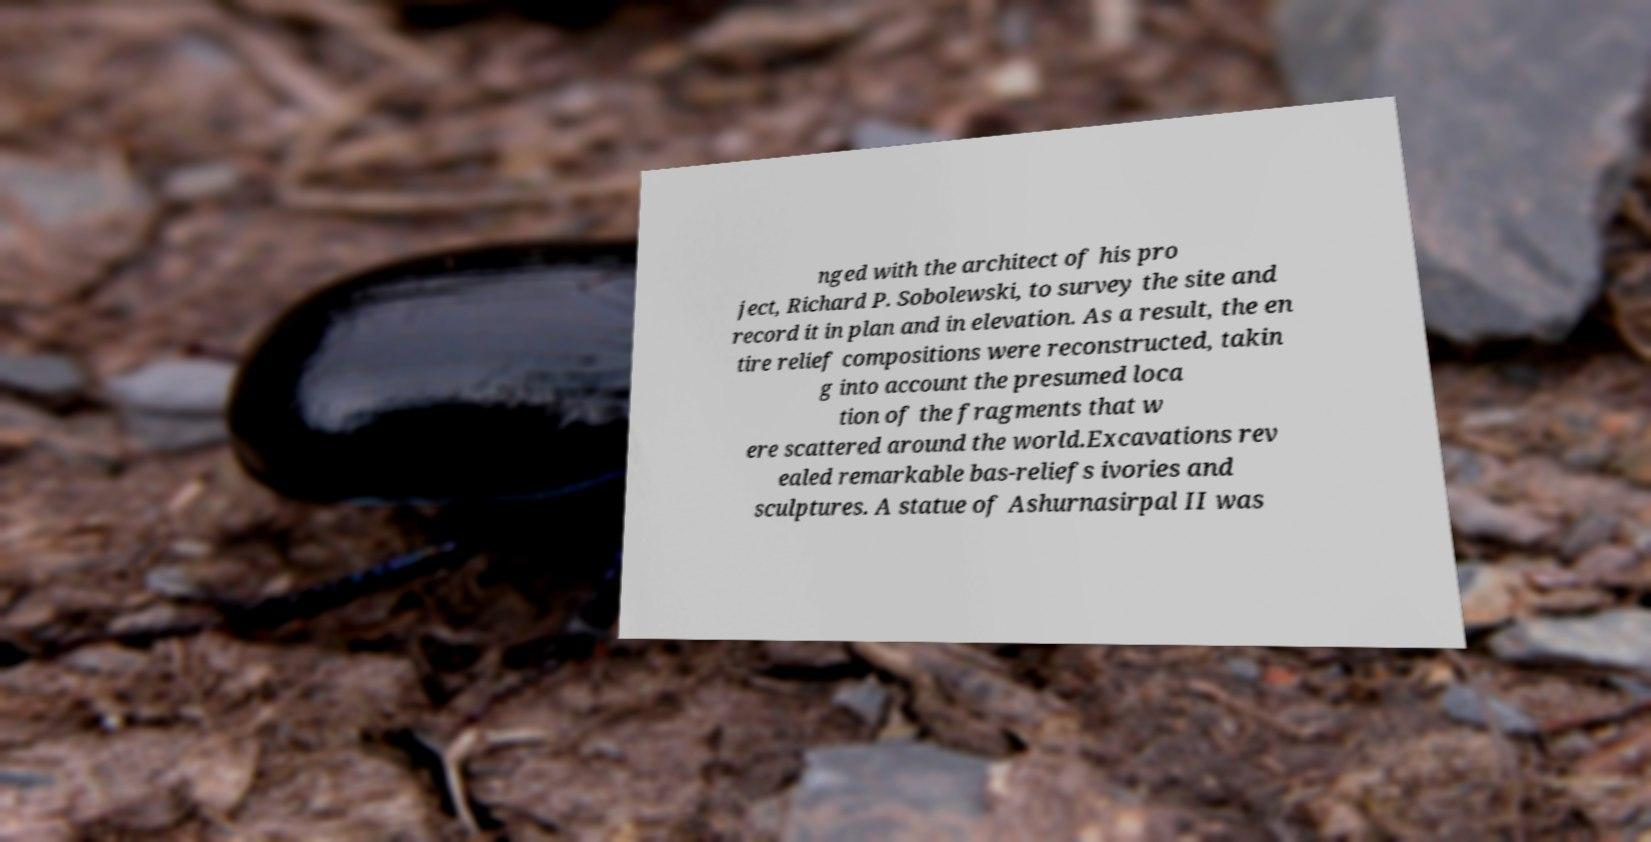For documentation purposes, I need the text within this image transcribed. Could you provide that? nged with the architect of his pro ject, Richard P. Sobolewski, to survey the site and record it in plan and in elevation. As a result, the en tire relief compositions were reconstructed, takin g into account the presumed loca tion of the fragments that w ere scattered around the world.Excavations rev ealed remarkable bas-reliefs ivories and sculptures. A statue of Ashurnasirpal II was 